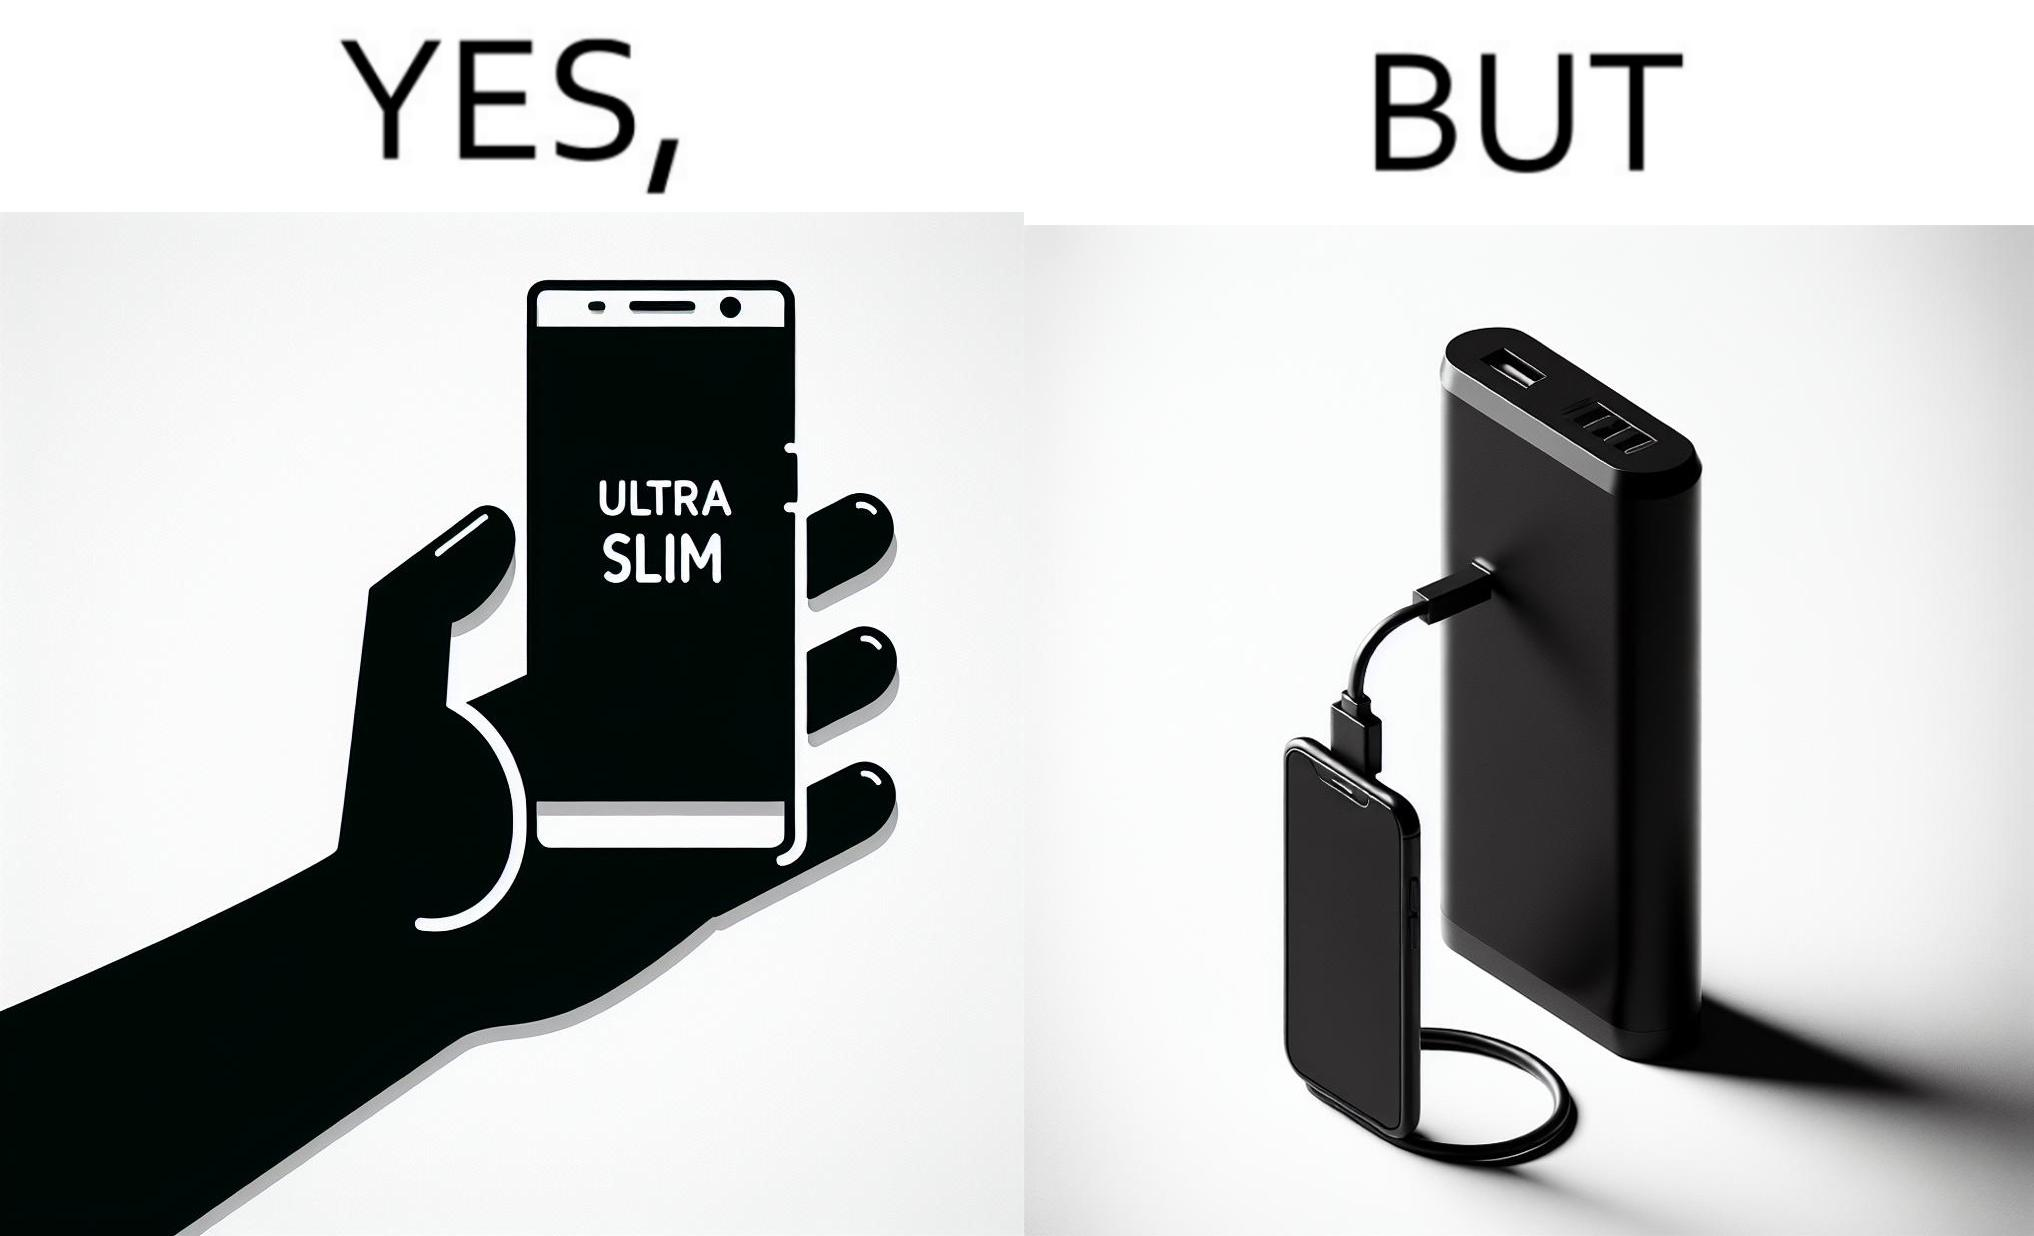Compare the left and right sides of this image. In the left part of the image: The image shows a hand holding a mobile phone with finger tips. The text on the screen of the mobile phone says "ULTRA SLIM".  The mobile phone is indeed very slim. In the right part of the image: The image shows a slim mobile phone connected to a thick,big and heavy power bank for charging the mobile phone. 